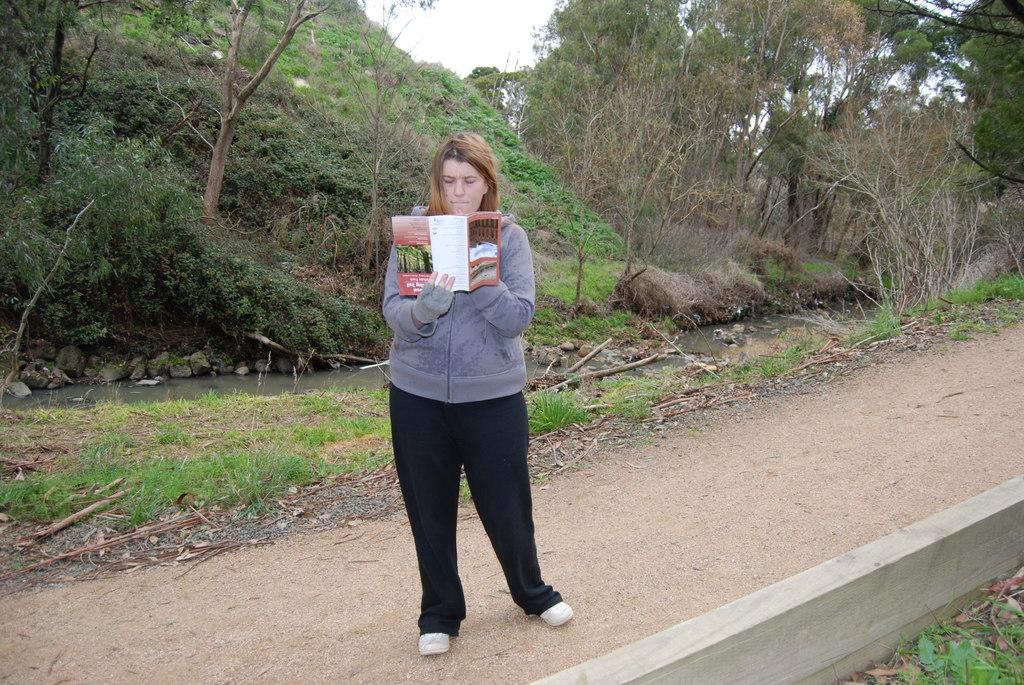What is the person in the image doing? The person is standing in the image and holding a book. What can be seen in the background of the image? There are trees, grass, and the sky visible in the background of the image. How many fingers does the person have on their left hand in the image? The image does not provide enough detail to determine the number of fingers on the person's left hand. 